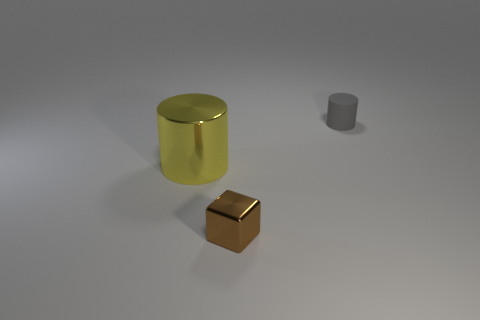Add 1 brown shiny blocks. How many objects exist? 4 Subtract 1 blocks. How many blocks are left? 0 Subtract all cubes. How many objects are left? 2 Subtract all green blocks. Subtract all green balls. How many blocks are left? 1 Subtract all brown cubes. How many yellow cylinders are left? 1 Subtract all big brown metallic things. Subtract all big yellow metal cylinders. How many objects are left? 2 Add 2 yellow cylinders. How many yellow cylinders are left? 3 Add 2 small gray matte things. How many small gray matte things exist? 3 Subtract 0 gray spheres. How many objects are left? 3 